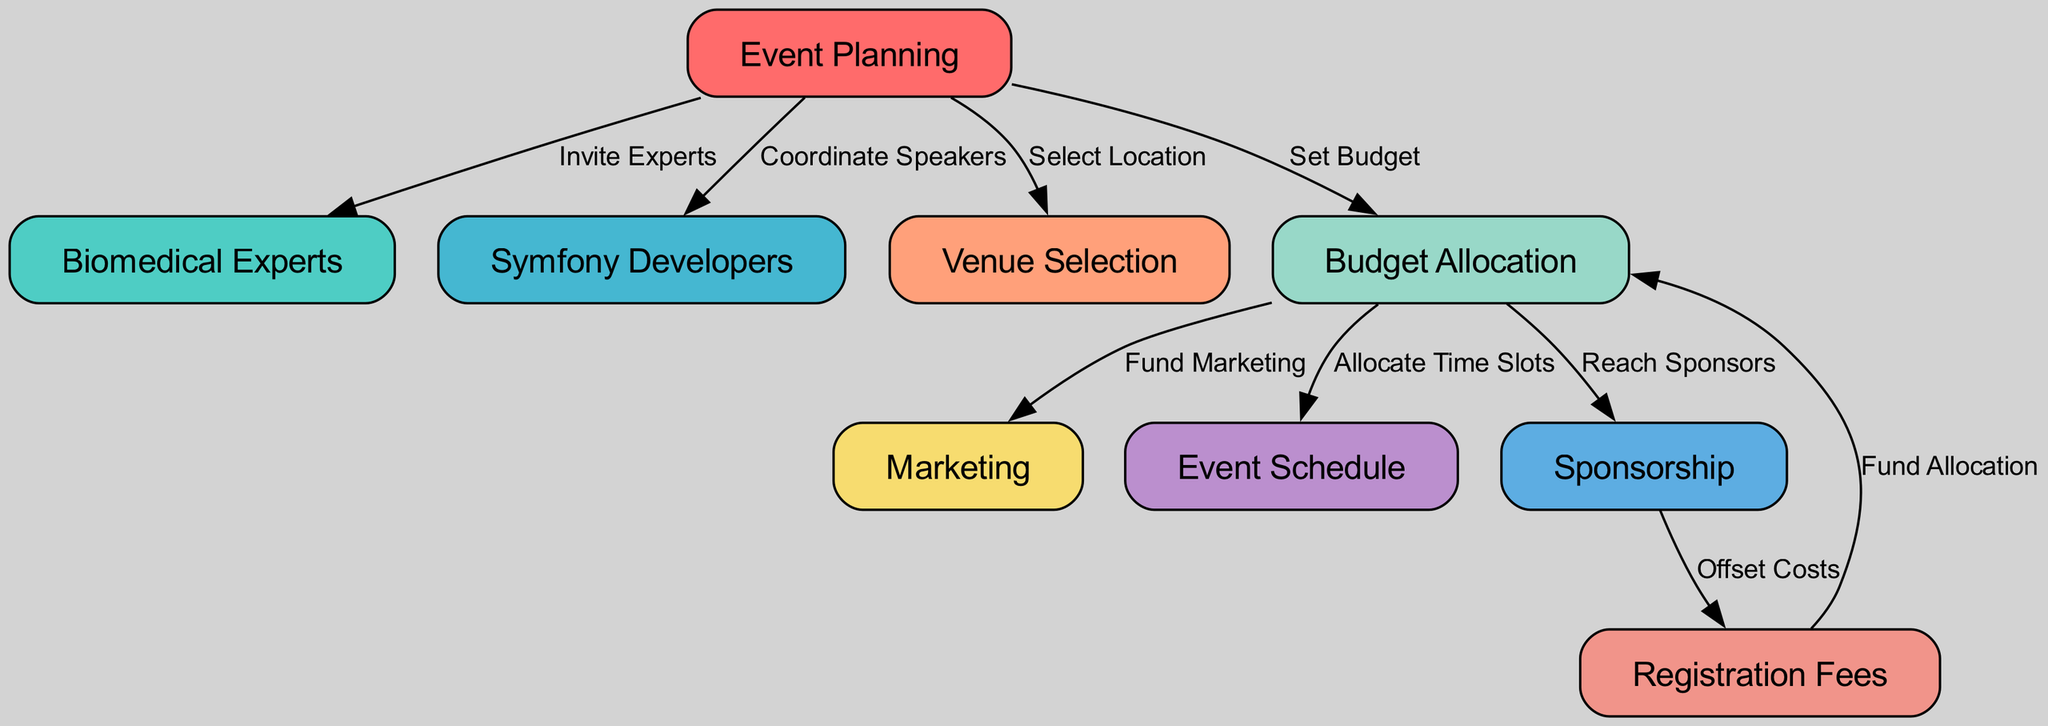What are the main components of event planning? The diagram includes several main components of event planning: Biomedical Experts, Symfony Developers, Venue Selection, Budget Allocation, Marketing, Event Schedule, Sponsorship, and Registration Fees. These nodes represent the critical elements involved in planning a biomedical event.
Answer: Biomedical Experts, Symfony Developers, Venue Selection, Budget Allocation, Marketing, Event Schedule, Sponsorship, Registration Fees How many edges are there in the diagram? By counting the connections (edges) between the nodes, we find there are a total of 8 edges depicted in the diagram. Each edge represents a relationship or action between two components of the planning process.
Answer: 8 What action is taken from Event Planning to Venue Selection? The edge connecting Event Planning to Venue Selection is labeled "Select Location," indicating the specific action taken in the event planning process related to choosing the venue for the event.
Answer: Select Location How does Budget Allocation influence Marketing? The edge from Budget Allocation to Marketing is labeled "Fund Marketing," suggesting that the funds allocated to the budget are used to support marketing efforts for the event. This establishes a direct link between budgeting and marketing activities.
Answer: Fund Marketing What is the relationship between Sponsorship and Registration Fees? The diagram shows an edge from Sponsorship to Registration Fees labeled "Offset Costs." This indicates that the sponsorship money received helps to reduce or cover the costs associated with registration fees, linking the financial support from sponsors to participant expenses.
Answer: Offset Costs What must be done before allocating time slots for the event? The diagram indicates that Budget Allocation must occur before the allocation of time slots for the event schedule. This is represented by the directional edge from Budget Allocation to Event Schedule, showing the necessary flow of actions in the planning process.
Answer: Set Budget Who must be invited in the event planning process? The action labeled "Invite Experts" leads from Event Planning to Biomedical Experts, showing that inviting experts is a vital step in the overall event planning process. This highlights the importance of involving knowledgeable individuals in the field.
Answer: Invite Experts What funds are used for Sponsorship? The edge from Budget Allocation to Sponsorship indicates that funds from budget allocation are used to "Reach Sponsors." This implies that the financial resources designated for sponsorship efforts come from the overall event budget.
Answer: Fund Marketing How does Registration Fees contribute back to Budget Allocation? The diagram shows that Registration Fees point back to Budget Allocation through the edge labeled "Fund Allocation." This illustrates that the fees collected from participants are reinvested into the budget for further allocation of resources.
Answer: Fund Allocation 